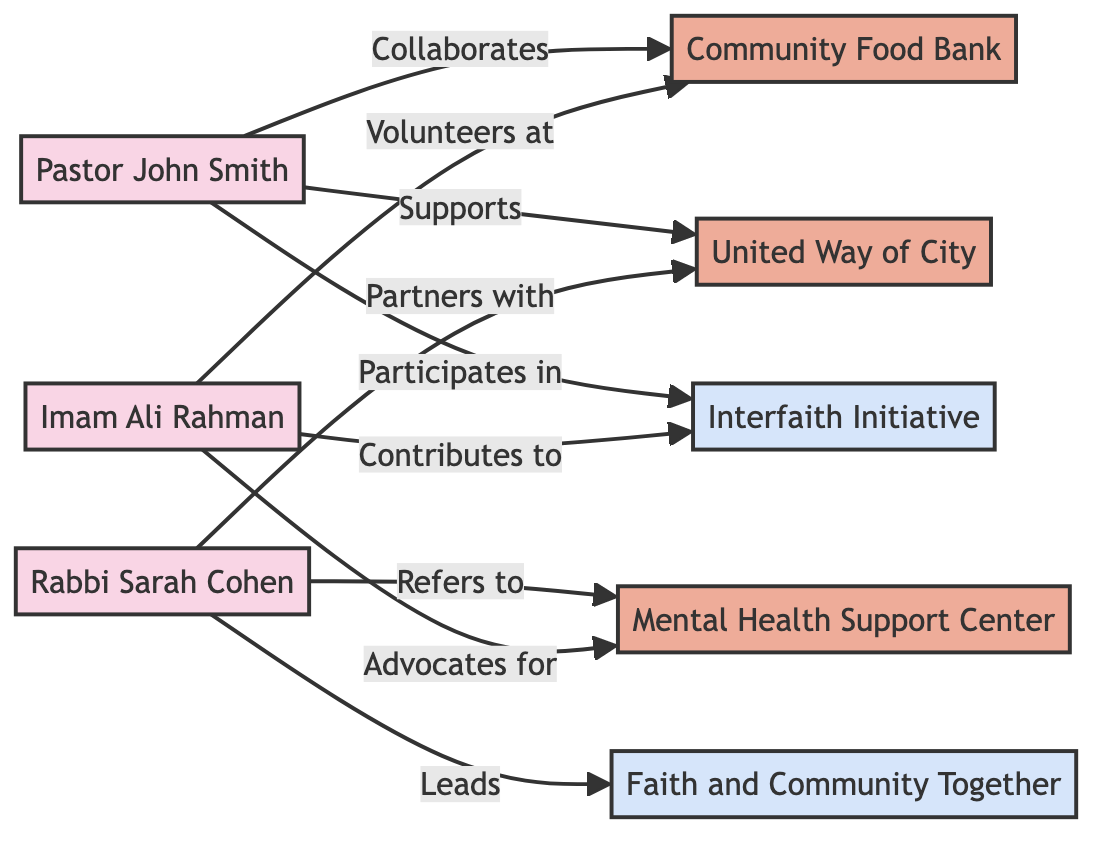What are the total number of local faith leaders shown in the diagram? The diagram lists three local faith leaders: Pastor John Smith, Rabbi Sarah Cohen, and Imam Ali Rahman. Counting these, we find a total of three local faith leaders.
Answer: 3 Which social service organization is associated with Pastor John Smith? The diagram shows two connections from Pastor John Smith: one to the Community Food Bank and another to United Way of City. Hence, both organizations are associated with him, but the question asks for one. The first stated is the Community Food Bank.
Answer: Community Food Bank Who leads the partnership labeled "Faith and Community Together"? The diagram connects Rabbi Sarah Cohen to the partnership labeled "Faith and Community Together". The labeled edge states she "Leads" this partnership.
Answer: Rabbi Sarah Cohen Which social service organization does Imam Ali Rahman volunteer at? The diagram indicates that Imam Ali Rahman has a direct connection labeled "Volunteers at" leading to the Community Food Bank. Thus, the organization he volunteers at is clear.
Answer: Community Food Bank How many partnerships are represented in the diagram? The diagram contains two partnerships: Interfaith Initiative and Faith and Community Together. Thus, counting these entities provides the total number of partnerships represented.
Answer: 2 Which local faith leader advocates for Mental Health Support Center? Imam Ali Rahman is connected to the Mental Health Support Center through the edge that states "Advocates for". Therefore, he is the local faith leader who advocates for this organization.
Answer: Imam Ali Rahman What types of relationships exist between the local faith leaders and the social service organizations? The diagram shows multiple relationship types, including "Collaborates", "Supports", "Partners with", "Refers to", "Volunteers at", and "Advocates for". Thus, various relationship types illustrate the connections between faith leaders and social service organizations.
Answer: Collaborates, Supports, Partners with, Refers to, Volunteers at, Advocates for Which local faith leader has the most connections to social service organizations? Analyzing the diagram: Pastor John Smith connects to Community Food Bank and United Way of City (2 connections), Rabbi Sarah Cohen connects to United Way of City and Mental Health Support Center (2 connections), and Imam Ali Rahman connects to Community Food Bank and Mental Health Support Center (2 connections). All have an equal number of connections, presenting no single leader with the most connections.
Answer: None 